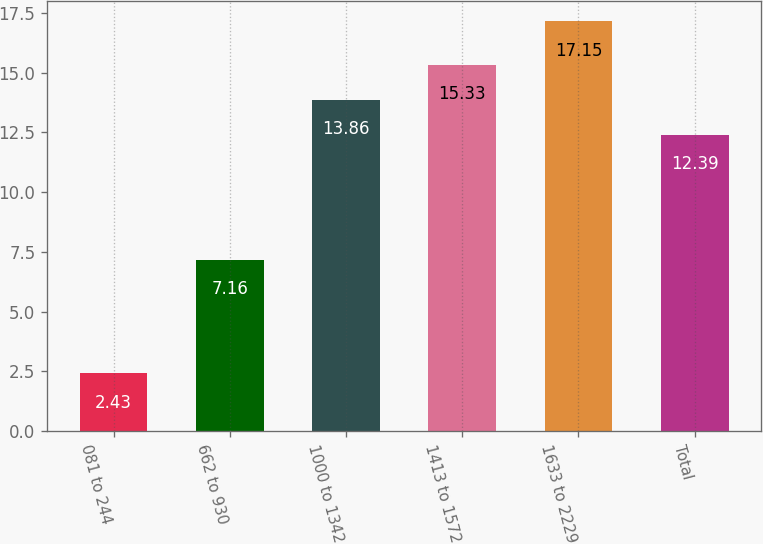Convert chart to OTSL. <chart><loc_0><loc_0><loc_500><loc_500><bar_chart><fcel>081 to 244<fcel>662 to 930<fcel>1000 to 1342<fcel>1413 to 1572<fcel>1633 to 2229<fcel>Total<nl><fcel>2.43<fcel>7.16<fcel>13.86<fcel>15.33<fcel>17.15<fcel>12.39<nl></chart> 